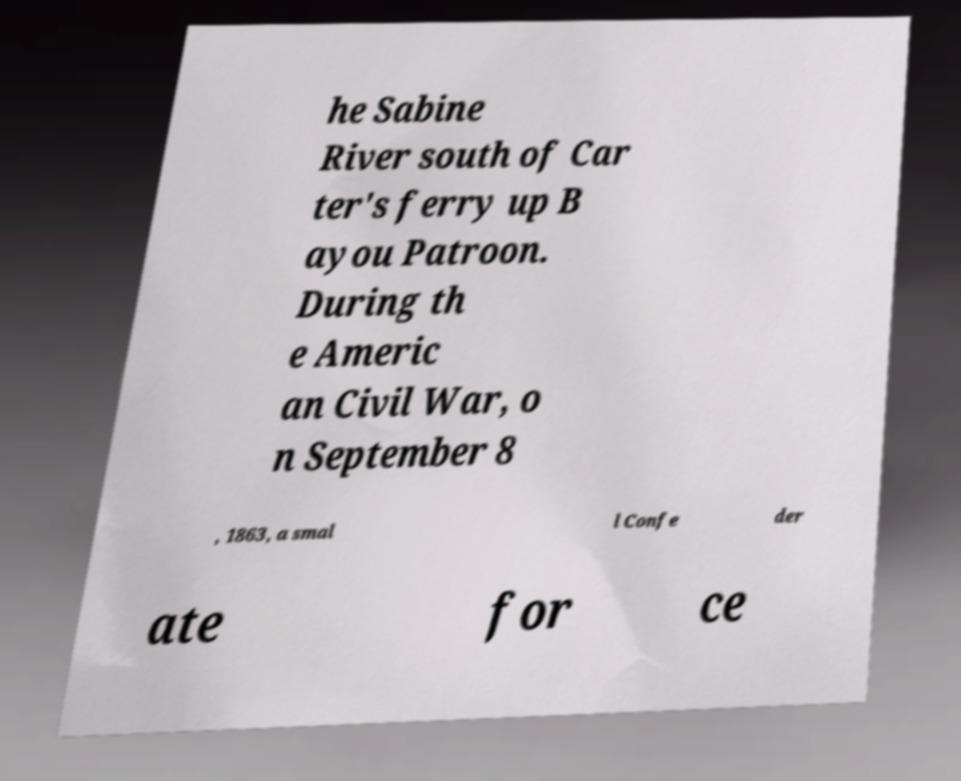Can you accurately transcribe the text from the provided image for me? he Sabine River south of Car ter's ferry up B ayou Patroon. During th e Americ an Civil War, o n September 8 , 1863, a smal l Confe der ate for ce 